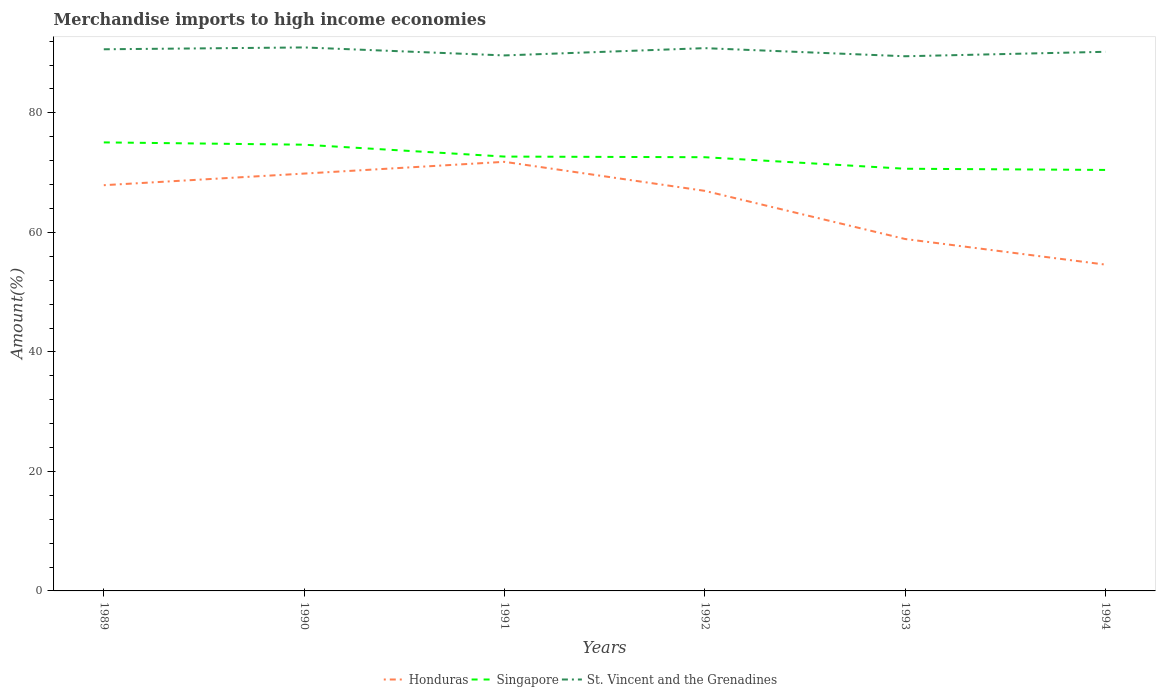How many different coloured lines are there?
Your answer should be very brief. 3. Is the number of lines equal to the number of legend labels?
Your response must be concise. Yes. Across all years, what is the maximum percentage of amount earned from merchandise imports in Singapore?
Your answer should be compact. 70.45. What is the total percentage of amount earned from merchandise imports in Honduras in the graph?
Offer a very short reply. 2.89. What is the difference between the highest and the second highest percentage of amount earned from merchandise imports in St. Vincent and the Grenadines?
Your answer should be compact. 1.48. Is the percentage of amount earned from merchandise imports in Honduras strictly greater than the percentage of amount earned from merchandise imports in Singapore over the years?
Provide a short and direct response. Yes. How many years are there in the graph?
Provide a short and direct response. 6. Are the values on the major ticks of Y-axis written in scientific E-notation?
Ensure brevity in your answer.  No. Where does the legend appear in the graph?
Make the answer very short. Bottom center. How many legend labels are there?
Your response must be concise. 3. What is the title of the graph?
Your response must be concise. Merchandise imports to high income economies. Does "Madagascar" appear as one of the legend labels in the graph?
Keep it short and to the point. No. What is the label or title of the Y-axis?
Make the answer very short. Amount(%). What is the Amount(%) in Honduras in 1989?
Make the answer very short. 67.9. What is the Amount(%) in Singapore in 1989?
Make the answer very short. 75.06. What is the Amount(%) of St. Vincent and the Grenadines in 1989?
Your answer should be compact. 90.65. What is the Amount(%) in Honduras in 1990?
Offer a very short reply. 69.84. What is the Amount(%) of Singapore in 1990?
Your response must be concise. 74.68. What is the Amount(%) of St. Vincent and the Grenadines in 1990?
Your answer should be very brief. 90.96. What is the Amount(%) in Honduras in 1991?
Keep it short and to the point. 71.81. What is the Amount(%) in Singapore in 1991?
Keep it short and to the point. 72.69. What is the Amount(%) in St. Vincent and the Grenadines in 1991?
Your response must be concise. 89.62. What is the Amount(%) in Honduras in 1992?
Provide a short and direct response. 66.95. What is the Amount(%) of Singapore in 1992?
Your answer should be very brief. 72.58. What is the Amount(%) in St. Vincent and the Grenadines in 1992?
Ensure brevity in your answer.  90.84. What is the Amount(%) of Honduras in 1993?
Offer a very short reply. 58.9. What is the Amount(%) in Singapore in 1993?
Make the answer very short. 70.65. What is the Amount(%) in St. Vincent and the Grenadines in 1993?
Provide a succinct answer. 89.48. What is the Amount(%) of Honduras in 1994?
Provide a short and direct response. 54.61. What is the Amount(%) in Singapore in 1994?
Offer a terse response. 70.45. What is the Amount(%) in St. Vincent and the Grenadines in 1994?
Make the answer very short. 90.23. Across all years, what is the maximum Amount(%) in Honduras?
Keep it short and to the point. 71.81. Across all years, what is the maximum Amount(%) of Singapore?
Ensure brevity in your answer.  75.06. Across all years, what is the maximum Amount(%) of St. Vincent and the Grenadines?
Your answer should be very brief. 90.96. Across all years, what is the minimum Amount(%) of Honduras?
Offer a very short reply. 54.61. Across all years, what is the minimum Amount(%) of Singapore?
Offer a very short reply. 70.45. Across all years, what is the minimum Amount(%) of St. Vincent and the Grenadines?
Offer a terse response. 89.48. What is the total Amount(%) of Honduras in the graph?
Ensure brevity in your answer.  390.01. What is the total Amount(%) of Singapore in the graph?
Provide a short and direct response. 436.12. What is the total Amount(%) of St. Vincent and the Grenadines in the graph?
Your response must be concise. 541.76. What is the difference between the Amount(%) in Honduras in 1989 and that in 1990?
Keep it short and to the point. -1.94. What is the difference between the Amount(%) of Singapore in 1989 and that in 1990?
Make the answer very short. 0.38. What is the difference between the Amount(%) in St. Vincent and the Grenadines in 1989 and that in 1990?
Your answer should be compact. -0.31. What is the difference between the Amount(%) in Honduras in 1989 and that in 1991?
Provide a succinct answer. -3.91. What is the difference between the Amount(%) in Singapore in 1989 and that in 1991?
Your response must be concise. 2.37. What is the difference between the Amount(%) in St. Vincent and the Grenadines in 1989 and that in 1991?
Offer a terse response. 1.03. What is the difference between the Amount(%) in Honduras in 1989 and that in 1992?
Your answer should be very brief. 0.95. What is the difference between the Amount(%) of Singapore in 1989 and that in 1992?
Provide a succinct answer. 2.48. What is the difference between the Amount(%) in St. Vincent and the Grenadines in 1989 and that in 1992?
Keep it short and to the point. -0.19. What is the difference between the Amount(%) of Honduras in 1989 and that in 1993?
Provide a short and direct response. 9. What is the difference between the Amount(%) of Singapore in 1989 and that in 1993?
Provide a short and direct response. 4.41. What is the difference between the Amount(%) of St. Vincent and the Grenadines in 1989 and that in 1993?
Provide a succinct answer. 1.17. What is the difference between the Amount(%) in Honduras in 1989 and that in 1994?
Provide a short and direct response. 13.29. What is the difference between the Amount(%) in Singapore in 1989 and that in 1994?
Offer a terse response. 4.61. What is the difference between the Amount(%) of St. Vincent and the Grenadines in 1989 and that in 1994?
Give a very brief answer. 0.42. What is the difference between the Amount(%) in Honduras in 1990 and that in 1991?
Your answer should be compact. -1.97. What is the difference between the Amount(%) in Singapore in 1990 and that in 1991?
Keep it short and to the point. 1.99. What is the difference between the Amount(%) of St. Vincent and the Grenadines in 1990 and that in 1991?
Offer a terse response. 1.34. What is the difference between the Amount(%) in Honduras in 1990 and that in 1992?
Offer a very short reply. 2.89. What is the difference between the Amount(%) in Singapore in 1990 and that in 1992?
Your answer should be very brief. 2.09. What is the difference between the Amount(%) in St. Vincent and the Grenadines in 1990 and that in 1992?
Give a very brief answer. 0.12. What is the difference between the Amount(%) of Honduras in 1990 and that in 1993?
Make the answer very short. 10.95. What is the difference between the Amount(%) of Singapore in 1990 and that in 1993?
Keep it short and to the point. 4.02. What is the difference between the Amount(%) in St. Vincent and the Grenadines in 1990 and that in 1993?
Your response must be concise. 1.48. What is the difference between the Amount(%) of Honduras in 1990 and that in 1994?
Ensure brevity in your answer.  15.23. What is the difference between the Amount(%) of Singapore in 1990 and that in 1994?
Keep it short and to the point. 4.22. What is the difference between the Amount(%) in St. Vincent and the Grenadines in 1990 and that in 1994?
Offer a very short reply. 0.73. What is the difference between the Amount(%) in Honduras in 1991 and that in 1992?
Keep it short and to the point. 4.86. What is the difference between the Amount(%) in Singapore in 1991 and that in 1992?
Your response must be concise. 0.11. What is the difference between the Amount(%) in St. Vincent and the Grenadines in 1991 and that in 1992?
Provide a short and direct response. -1.22. What is the difference between the Amount(%) in Honduras in 1991 and that in 1993?
Make the answer very short. 12.92. What is the difference between the Amount(%) in Singapore in 1991 and that in 1993?
Give a very brief answer. 2.04. What is the difference between the Amount(%) of St. Vincent and the Grenadines in 1991 and that in 1993?
Offer a terse response. 0.14. What is the difference between the Amount(%) of Honduras in 1991 and that in 1994?
Make the answer very short. 17.2. What is the difference between the Amount(%) of Singapore in 1991 and that in 1994?
Make the answer very short. 2.24. What is the difference between the Amount(%) in St. Vincent and the Grenadines in 1991 and that in 1994?
Provide a succinct answer. -0.61. What is the difference between the Amount(%) of Honduras in 1992 and that in 1993?
Offer a terse response. 8.06. What is the difference between the Amount(%) in Singapore in 1992 and that in 1993?
Offer a very short reply. 1.93. What is the difference between the Amount(%) in St. Vincent and the Grenadines in 1992 and that in 1993?
Your answer should be very brief. 1.36. What is the difference between the Amount(%) of Honduras in 1992 and that in 1994?
Give a very brief answer. 12.34. What is the difference between the Amount(%) of Singapore in 1992 and that in 1994?
Make the answer very short. 2.13. What is the difference between the Amount(%) of St. Vincent and the Grenadines in 1992 and that in 1994?
Provide a short and direct response. 0.61. What is the difference between the Amount(%) of Honduras in 1993 and that in 1994?
Make the answer very short. 4.29. What is the difference between the Amount(%) in Singapore in 1993 and that in 1994?
Offer a terse response. 0.2. What is the difference between the Amount(%) in St. Vincent and the Grenadines in 1993 and that in 1994?
Make the answer very short. -0.75. What is the difference between the Amount(%) in Honduras in 1989 and the Amount(%) in Singapore in 1990?
Offer a very short reply. -6.78. What is the difference between the Amount(%) in Honduras in 1989 and the Amount(%) in St. Vincent and the Grenadines in 1990?
Make the answer very short. -23.06. What is the difference between the Amount(%) in Singapore in 1989 and the Amount(%) in St. Vincent and the Grenadines in 1990?
Your response must be concise. -15.89. What is the difference between the Amount(%) in Honduras in 1989 and the Amount(%) in Singapore in 1991?
Keep it short and to the point. -4.79. What is the difference between the Amount(%) of Honduras in 1989 and the Amount(%) of St. Vincent and the Grenadines in 1991?
Your answer should be very brief. -21.72. What is the difference between the Amount(%) in Singapore in 1989 and the Amount(%) in St. Vincent and the Grenadines in 1991?
Offer a terse response. -14.56. What is the difference between the Amount(%) in Honduras in 1989 and the Amount(%) in Singapore in 1992?
Ensure brevity in your answer.  -4.68. What is the difference between the Amount(%) of Honduras in 1989 and the Amount(%) of St. Vincent and the Grenadines in 1992?
Keep it short and to the point. -22.94. What is the difference between the Amount(%) in Singapore in 1989 and the Amount(%) in St. Vincent and the Grenadines in 1992?
Offer a very short reply. -15.77. What is the difference between the Amount(%) of Honduras in 1989 and the Amount(%) of Singapore in 1993?
Give a very brief answer. -2.75. What is the difference between the Amount(%) of Honduras in 1989 and the Amount(%) of St. Vincent and the Grenadines in 1993?
Offer a terse response. -21.58. What is the difference between the Amount(%) in Singapore in 1989 and the Amount(%) in St. Vincent and the Grenadines in 1993?
Your answer should be very brief. -14.42. What is the difference between the Amount(%) of Honduras in 1989 and the Amount(%) of Singapore in 1994?
Provide a succinct answer. -2.55. What is the difference between the Amount(%) of Honduras in 1989 and the Amount(%) of St. Vincent and the Grenadines in 1994?
Your answer should be very brief. -22.33. What is the difference between the Amount(%) of Singapore in 1989 and the Amount(%) of St. Vincent and the Grenadines in 1994?
Keep it short and to the point. -15.16. What is the difference between the Amount(%) of Honduras in 1990 and the Amount(%) of Singapore in 1991?
Provide a short and direct response. -2.85. What is the difference between the Amount(%) of Honduras in 1990 and the Amount(%) of St. Vincent and the Grenadines in 1991?
Ensure brevity in your answer.  -19.77. What is the difference between the Amount(%) in Singapore in 1990 and the Amount(%) in St. Vincent and the Grenadines in 1991?
Ensure brevity in your answer.  -14.94. What is the difference between the Amount(%) in Honduras in 1990 and the Amount(%) in Singapore in 1992?
Your response must be concise. -2.74. What is the difference between the Amount(%) in Honduras in 1990 and the Amount(%) in St. Vincent and the Grenadines in 1992?
Your answer should be compact. -20.99. What is the difference between the Amount(%) of Singapore in 1990 and the Amount(%) of St. Vincent and the Grenadines in 1992?
Your answer should be very brief. -16.16. What is the difference between the Amount(%) in Honduras in 1990 and the Amount(%) in Singapore in 1993?
Offer a terse response. -0.81. What is the difference between the Amount(%) of Honduras in 1990 and the Amount(%) of St. Vincent and the Grenadines in 1993?
Provide a succinct answer. -19.64. What is the difference between the Amount(%) in Singapore in 1990 and the Amount(%) in St. Vincent and the Grenadines in 1993?
Ensure brevity in your answer.  -14.8. What is the difference between the Amount(%) of Honduras in 1990 and the Amount(%) of Singapore in 1994?
Ensure brevity in your answer.  -0.61. What is the difference between the Amount(%) in Honduras in 1990 and the Amount(%) in St. Vincent and the Grenadines in 1994?
Provide a short and direct response. -20.38. What is the difference between the Amount(%) in Singapore in 1990 and the Amount(%) in St. Vincent and the Grenadines in 1994?
Ensure brevity in your answer.  -15.55. What is the difference between the Amount(%) of Honduras in 1991 and the Amount(%) of Singapore in 1992?
Your answer should be very brief. -0.77. What is the difference between the Amount(%) of Honduras in 1991 and the Amount(%) of St. Vincent and the Grenadines in 1992?
Give a very brief answer. -19.02. What is the difference between the Amount(%) in Singapore in 1991 and the Amount(%) in St. Vincent and the Grenadines in 1992?
Your answer should be very brief. -18.15. What is the difference between the Amount(%) of Honduras in 1991 and the Amount(%) of Singapore in 1993?
Your answer should be compact. 1.16. What is the difference between the Amount(%) of Honduras in 1991 and the Amount(%) of St. Vincent and the Grenadines in 1993?
Offer a very short reply. -17.67. What is the difference between the Amount(%) of Singapore in 1991 and the Amount(%) of St. Vincent and the Grenadines in 1993?
Your response must be concise. -16.79. What is the difference between the Amount(%) in Honduras in 1991 and the Amount(%) in Singapore in 1994?
Your answer should be compact. 1.36. What is the difference between the Amount(%) in Honduras in 1991 and the Amount(%) in St. Vincent and the Grenadines in 1994?
Make the answer very short. -18.41. What is the difference between the Amount(%) of Singapore in 1991 and the Amount(%) of St. Vincent and the Grenadines in 1994?
Keep it short and to the point. -17.54. What is the difference between the Amount(%) in Honduras in 1992 and the Amount(%) in Singapore in 1993?
Ensure brevity in your answer.  -3.7. What is the difference between the Amount(%) of Honduras in 1992 and the Amount(%) of St. Vincent and the Grenadines in 1993?
Your answer should be very brief. -22.52. What is the difference between the Amount(%) in Singapore in 1992 and the Amount(%) in St. Vincent and the Grenadines in 1993?
Keep it short and to the point. -16.9. What is the difference between the Amount(%) in Honduras in 1992 and the Amount(%) in Singapore in 1994?
Keep it short and to the point. -3.5. What is the difference between the Amount(%) of Honduras in 1992 and the Amount(%) of St. Vincent and the Grenadines in 1994?
Make the answer very short. -23.27. What is the difference between the Amount(%) in Singapore in 1992 and the Amount(%) in St. Vincent and the Grenadines in 1994?
Provide a succinct answer. -17.64. What is the difference between the Amount(%) in Honduras in 1993 and the Amount(%) in Singapore in 1994?
Keep it short and to the point. -11.56. What is the difference between the Amount(%) in Honduras in 1993 and the Amount(%) in St. Vincent and the Grenadines in 1994?
Make the answer very short. -31.33. What is the difference between the Amount(%) in Singapore in 1993 and the Amount(%) in St. Vincent and the Grenadines in 1994?
Provide a short and direct response. -19.57. What is the average Amount(%) in Honduras per year?
Give a very brief answer. 65. What is the average Amount(%) of Singapore per year?
Make the answer very short. 72.69. What is the average Amount(%) in St. Vincent and the Grenadines per year?
Ensure brevity in your answer.  90.29. In the year 1989, what is the difference between the Amount(%) of Honduras and Amount(%) of Singapore?
Your answer should be compact. -7.16. In the year 1989, what is the difference between the Amount(%) of Honduras and Amount(%) of St. Vincent and the Grenadines?
Your answer should be very brief. -22.75. In the year 1989, what is the difference between the Amount(%) of Singapore and Amount(%) of St. Vincent and the Grenadines?
Keep it short and to the point. -15.58. In the year 1990, what is the difference between the Amount(%) in Honduras and Amount(%) in Singapore?
Your response must be concise. -4.83. In the year 1990, what is the difference between the Amount(%) of Honduras and Amount(%) of St. Vincent and the Grenadines?
Offer a terse response. -21.11. In the year 1990, what is the difference between the Amount(%) in Singapore and Amount(%) in St. Vincent and the Grenadines?
Offer a very short reply. -16.28. In the year 1991, what is the difference between the Amount(%) in Honduras and Amount(%) in Singapore?
Your answer should be very brief. -0.88. In the year 1991, what is the difference between the Amount(%) in Honduras and Amount(%) in St. Vincent and the Grenadines?
Provide a succinct answer. -17.81. In the year 1991, what is the difference between the Amount(%) in Singapore and Amount(%) in St. Vincent and the Grenadines?
Keep it short and to the point. -16.93. In the year 1992, what is the difference between the Amount(%) in Honduras and Amount(%) in Singapore?
Ensure brevity in your answer.  -5.63. In the year 1992, what is the difference between the Amount(%) of Honduras and Amount(%) of St. Vincent and the Grenadines?
Keep it short and to the point. -23.88. In the year 1992, what is the difference between the Amount(%) in Singapore and Amount(%) in St. Vincent and the Grenadines?
Provide a short and direct response. -18.25. In the year 1993, what is the difference between the Amount(%) in Honduras and Amount(%) in Singapore?
Offer a very short reply. -11.76. In the year 1993, what is the difference between the Amount(%) in Honduras and Amount(%) in St. Vincent and the Grenadines?
Keep it short and to the point. -30.58. In the year 1993, what is the difference between the Amount(%) in Singapore and Amount(%) in St. Vincent and the Grenadines?
Your answer should be compact. -18.82. In the year 1994, what is the difference between the Amount(%) of Honduras and Amount(%) of Singapore?
Ensure brevity in your answer.  -15.84. In the year 1994, what is the difference between the Amount(%) in Honduras and Amount(%) in St. Vincent and the Grenadines?
Your answer should be compact. -35.62. In the year 1994, what is the difference between the Amount(%) of Singapore and Amount(%) of St. Vincent and the Grenadines?
Provide a short and direct response. -19.77. What is the ratio of the Amount(%) in Honduras in 1989 to that in 1990?
Provide a succinct answer. 0.97. What is the ratio of the Amount(%) in St. Vincent and the Grenadines in 1989 to that in 1990?
Keep it short and to the point. 1. What is the ratio of the Amount(%) in Honduras in 1989 to that in 1991?
Keep it short and to the point. 0.95. What is the ratio of the Amount(%) of Singapore in 1989 to that in 1991?
Offer a terse response. 1.03. What is the ratio of the Amount(%) in St. Vincent and the Grenadines in 1989 to that in 1991?
Provide a succinct answer. 1.01. What is the ratio of the Amount(%) in Honduras in 1989 to that in 1992?
Provide a succinct answer. 1.01. What is the ratio of the Amount(%) of Singapore in 1989 to that in 1992?
Provide a short and direct response. 1.03. What is the ratio of the Amount(%) in St. Vincent and the Grenadines in 1989 to that in 1992?
Your answer should be compact. 1. What is the ratio of the Amount(%) of Honduras in 1989 to that in 1993?
Your answer should be very brief. 1.15. What is the ratio of the Amount(%) of Singapore in 1989 to that in 1993?
Ensure brevity in your answer.  1.06. What is the ratio of the Amount(%) of St. Vincent and the Grenadines in 1989 to that in 1993?
Ensure brevity in your answer.  1.01. What is the ratio of the Amount(%) of Honduras in 1989 to that in 1994?
Your answer should be very brief. 1.24. What is the ratio of the Amount(%) of Singapore in 1989 to that in 1994?
Your response must be concise. 1.07. What is the ratio of the Amount(%) of St. Vincent and the Grenadines in 1989 to that in 1994?
Offer a terse response. 1. What is the ratio of the Amount(%) of Honduras in 1990 to that in 1991?
Ensure brevity in your answer.  0.97. What is the ratio of the Amount(%) in Singapore in 1990 to that in 1991?
Your response must be concise. 1.03. What is the ratio of the Amount(%) in St. Vincent and the Grenadines in 1990 to that in 1991?
Offer a very short reply. 1.01. What is the ratio of the Amount(%) in Honduras in 1990 to that in 1992?
Ensure brevity in your answer.  1.04. What is the ratio of the Amount(%) in Singapore in 1990 to that in 1992?
Ensure brevity in your answer.  1.03. What is the ratio of the Amount(%) in Honduras in 1990 to that in 1993?
Your response must be concise. 1.19. What is the ratio of the Amount(%) of Singapore in 1990 to that in 1993?
Your response must be concise. 1.06. What is the ratio of the Amount(%) of St. Vincent and the Grenadines in 1990 to that in 1993?
Provide a succinct answer. 1.02. What is the ratio of the Amount(%) in Honduras in 1990 to that in 1994?
Offer a very short reply. 1.28. What is the ratio of the Amount(%) of Singapore in 1990 to that in 1994?
Provide a succinct answer. 1.06. What is the ratio of the Amount(%) in St. Vincent and the Grenadines in 1990 to that in 1994?
Make the answer very short. 1.01. What is the ratio of the Amount(%) of Honduras in 1991 to that in 1992?
Your answer should be compact. 1.07. What is the ratio of the Amount(%) in Singapore in 1991 to that in 1992?
Keep it short and to the point. 1. What is the ratio of the Amount(%) of St. Vincent and the Grenadines in 1991 to that in 1992?
Make the answer very short. 0.99. What is the ratio of the Amount(%) in Honduras in 1991 to that in 1993?
Offer a terse response. 1.22. What is the ratio of the Amount(%) of Singapore in 1991 to that in 1993?
Offer a very short reply. 1.03. What is the ratio of the Amount(%) in Honduras in 1991 to that in 1994?
Provide a succinct answer. 1.31. What is the ratio of the Amount(%) in Singapore in 1991 to that in 1994?
Ensure brevity in your answer.  1.03. What is the ratio of the Amount(%) in Honduras in 1992 to that in 1993?
Keep it short and to the point. 1.14. What is the ratio of the Amount(%) in Singapore in 1992 to that in 1993?
Provide a succinct answer. 1.03. What is the ratio of the Amount(%) of St. Vincent and the Grenadines in 1992 to that in 1993?
Offer a very short reply. 1.02. What is the ratio of the Amount(%) in Honduras in 1992 to that in 1994?
Ensure brevity in your answer.  1.23. What is the ratio of the Amount(%) in Singapore in 1992 to that in 1994?
Offer a terse response. 1.03. What is the ratio of the Amount(%) in St. Vincent and the Grenadines in 1992 to that in 1994?
Give a very brief answer. 1.01. What is the ratio of the Amount(%) in Honduras in 1993 to that in 1994?
Keep it short and to the point. 1.08. What is the difference between the highest and the second highest Amount(%) of Honduras?
Provide a succinct answer. 1.97. What is the difference between the highest and the second highest Amount(%) of Singapore?
Provide a short and direct response. 0.38. What is the difference between the highest and the second highest Amount(%) of St. Vincent and the Grenadines?
Provide a short and direct response. 0.12. What is the difference between the highest and the lowest Amount(%) of Honduras?
Provide a short and direct response. 17.2. What is the difference between the highest and the lowest Amount(%) of Singapore?
Make the answer very short. 4.61. What is the difference between the highest and the lowest Amount(%) in St. Vincent and the Grenadines?
Your response must be concise. 1.48. 